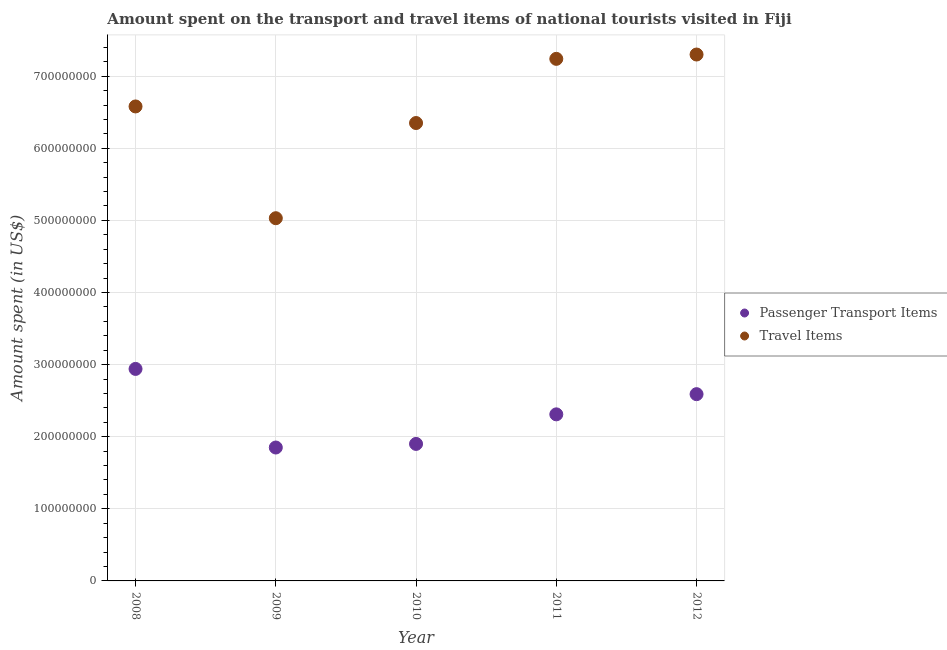What is the amount spent in travel items in 2012?
Your response must be concise. 7.30e+08. Across all years, what is the maximum amount spent in travel items?
Make the answer very short. 7.30e+08. Across all years, what is the minimum amount spent in travel items?
Keep it short and to the point. 5.03e+08. In which year was the amount spent on passenger transport items maximum?
Offer a very short reply. 2008. What is the total amount spent in travel items in the graph?
Ensure brevity in your answer.  3.25e+09. What is the difference between the amount spent on passenger transport items in 2009 and that in 2010?
Your answer should be compact. -5.00e+06. What is the difference between the amount spent in travel items in 2011 and the amount spent on passenger transport items in 2012?
Your answer should be very brief. 4.65e+08. What is the average amount spent on passenger transport items per year?
Provide a succinct answer. 2.32e+08. In the year 2009, what is the difference between the amount spent on passenger transport items and amount spent in travel items?
Offer a very short reply. -3.18e+08. What is the ratio of the amount spent in travel items in 2008 to that in 2010?
Offer a very short reply. 1.04. Is the amount spent on passenger transport items in 2009 less than that in 2010?
Your answer should be very brief. Yes. Is the difference between the amount spent in travel items in 2011 and 2012 greater than the difference between the amount spent on passenger transport items in 2011 and 2012?
Your response must be concise. Yes. What is the difference between the highest and the second highest amount spent on passenger transport items?
Your response must be concise. 3.50e+07. What is the difference between the highest and the lowest amount spent in travel items?
Ensure brevity in your answer.  2.27e+08. In how many years, is the amount spent on passenger transport items greater than the average amount spent on passenger transport items taken over all years?
Offer a very short reply. 2. How many dotlines are there?
Offer a very short reply. 2. How many years are there in the graph?
Give a very brief answer. 5. Are the values on the major ticks of Y-axis written in scientific E-notation?
Provide a succinct answer. No. Does the graph contain grids?
Your answer should be very brief. Yes. How are the legend labels stacked?
Give a very brief answer. Vertical. What is the title of the graph?
Provide a short and direct response. Amount spent on the transport and travel items of national tourists visited in Fiji. What is the label or title of the X-axis?
Keep it short and to the point. Year. What is the label or title of the Y-axis?
Keep it short and to the point. Amount spent (in US$). What is the Amount spent (in US$) in Passenger Transport Items in 2008?
Your response must be concise. 2.94e+08. What is the Amount spent (in US$) in Travel Items in 2008?
Offer a terse response. 6.58e+08. What is the Amount spent (in US$) of Passenger Transport Items in 2009?
Provide a succinct answer. 1.85e+08. What is the Amount spent (in US$) in Travel Items in 2009?
Your response must be concise. 5.03e+08. What is the Amount spent (in US$) of Passenger Transport Items in 2010?
Offer a very short reply. 1.90e+08. What is the Amount spent (in US$) of Travel Items in 2010?
Your answer should be very brief. 6.35e+08. What is the Amount spent (in US$) of Passenger Transport Items in 2011?
Your answer should be very brief. 2.31e+08. What is the Amount spent (in US$) of Travel Items in 2011?
Make the answer very short. 7.24e+08. What is the Amount spent (in US$) of Passenger Transport Items in 2012?
Keep it short and to the point. 2.59e+08. What is the Amount spent (in US$) of Travel Items in 2012?
Your answer should be very brief. 7.30e+08. Across all years, what is the maximum Amount spent (in US$) of Passenger Transport Items?
Ensure brevity in your answer.  2.94e+08. Across all years, what is the maximum Amount spent (in US$) in Travel Items?
Provide a succinct answer. 7.30e+08. Across all years, what is the minimum Amount spent (in US$) of Passenger Transport Items?
Provide a short and direct response. 1.85e+08. Across all years, what is the minimum Amount spent (in US$) of Travel Items?
Your answer should be very brief. 5.03e+08. What is the total Amount spent (in US$) of Passenger Transport Items in the graph?
Give a very brief answer. 1.16e+09. What is the total Amount spent (in US$) of Travel Items in the graph?
Provide a short and direct response. 3.25e+09. What is the difference between the Amount spent (in US$) in Passenger Transport Items in 2008 and that in 2009?
Make the answer very short. 1.09e+08. What is the difference between the Amount spent (in US$) of Travel Items in 2008 and that in 2009?
Your response must be concise. 1.55e+08. What is the difference between the Amount spent (in US$) of Passenger Transport Items in 2008 and that in 2010?
Offer a terse response. 1.04e+08. What is the difference between the Amount spent (in US$) in Travel Items in 2008 and that in 2010?
Provide a succinct answer. 2.30e+07. What is the difference between the Amount spent (in US$) in Passenger Transport Items in 2008 and that in 2011?
Keep it short and to the point. 6.30e+07. What is the difference between the Amount spent (in US$) of Travel Items in 2008 and that in 2011?
Your response must be concise. -6.60e+07. What is the difference between the Amount spent (in US$) of Passenger Transport Items in 2008 and that in 2012?
Ensure brevity in your answer.  3.50e+07. What is the difference between the Amount spent (in US$) in Travel Items in 2008 and that in 2012?
Keep it short and to the point. -7.20e+07. What is the difference between the Amount spent (in US$) of Passenger Transport Items in 2009 and that in 2010?
Ensure brevity in your answer.  -5.00e+06. What is the difference between the Amount spent (in US$) in Travel Items in 2009 and that in 2010?
Ensure brevity in your answer.  -1.32e+08. What is the difference between the Amount spent (in US$) in Passenger Transport Items in 2009 and that in 2011?
Ensure brevity in your answer.  -4.60e+07. What is the difference between the Amount spent (in US$) in Travel Items in 2009 and that in 2011?
Ensure brevity in your answer.  -2.21e+08. What is the difference between the Amount spent (in US$) of Passenger Transport Items in 2009 and that in 2012?
Make the answer very short. -7.40e+07. What is the difference between the Amount spent (in US$) in Travel Items in 2009 and that in 2012?
Offer a terse response. -2.27e+08. What is the difference between the Amount spent (in US$) of Passenger Transport Items in 2010 and that in 2011?
Your response must be concise. -4.10e+07. What is the difference between the Amount spent (in US$) of Travel Items in 2010 and that in 2011?
Your answer should be very brief. -8.90e+07. What is the difference between the Amount spent (in US$) in Passenger Transport Items in 2010 and that in 2012?
Ensure brevity in your answer.  -6.90e+07. What is the difference between the Amount spent (in US$) of Travel Items in 2010 and that in 2012?
Offer a very short reply. -9.50e+07. What is the difference between the Amount spent (in US$) of Passenger Transport Items in 2011 and that in 2012?
Your answer should be very brief. -2.80e+07. What is the difference between the Amount spent (in US$) in Travel Items in 2011 and that in 2012?
Your answer should be very brief. -6.00e+06. What is the difference between the Amount spent (in US$) in Passenger Transport Items in 2008 and the Amount spent (in US$) in Travel Items in 2009?
Give a very brief answer. -2.09e+08. What is the difference between the Amount spent (in US$) of Passenger Transport Items in 2008 and the Amount spent (in US$) of Travel Items in 2010?
Provide a short and direct response. -3.41e+08. What is the difference between the Amount spent (in US$) of Passenger Transport Items in 2008 and the Amount spent (in US$) of Travel Items in 2011?
Provide a succinct answer. -4.30e+08. What is the difference between the Amount spent (in US$) of Passenger Transport Items in 2008 and the Amount spent (in US$) of Travel Items in 2012?
Give a very brief answer. -4.36e+08. What is the difference between the Amount spent (in US$) in Passenger Transport Items in 2009 and the Amount spent (in US$) in Travel Items in 2010?
Your answer should be very brief. -4.50e+08. What is the difference between the Amount spent (in US$) of Passenger Transport Items in 2009 and the Amount spent (in US$) of Travel Items in 2011?
Your response must be concise. -5.39e+08. What is the difference between the Amount spent (in US$) of Passenger Transport Items in 2009 and the Amount spent (in US$) of Travel Items in 2012?
Provide a succinct answer. -5.45e+08. What is the difference between the Amount spent (in US$) in Passenger Transport Items in 2010 and the Amount spent (in US$) in Travel Items in 2011?
Your response must be concise. -5.34e+08. What is the difference between the Amount spent (in US$) of Passenger Transport Items in 2010 and the Amount spent (in US$) of Travel Items in 2012?
Keep it short and to the point. -5.40e+08. What is the difference between the Amount spent (in US$) in Passenger Transport Items in 2011 and the Amount spent (in US$) in Travel Items in 2012?
Provide a short and direct response. -4.99e+08. What is the average Amount spent (in US$) in Passenger Transport Items per year?
Offer a very short reply. 2.32e+08. What is the average Amount spent (in US$) of Travel Items per year?
Provide a short and direct response. 6.50e+08. In the year 2008, what is the difference between the Amount spent (in US$) in Passenger Transport Items and Amount spent (in US$) in Travel Items?
Offer a terse response. -3.64e+08. In the year 2009, what is the difference between the Amount spent (in US$) in Passenger Transport Items and Amount spent (in US$) in Travel Items?
Your response must be concise. -3.18e+08. In the year 2010, what is the difference between the Amount spent (in US$) in Passenger Transport Items and Amount spent (in US$) in Travel Items?
Offer a terse response. -4.45e+08. In the year 2011, what is the difference between the Amount spent (in US$) of Passenger Transport Items and Amount spent (in US$) of Travel Items?
Keep it short and to the point. -4.93e+08. In the year 2012, what is the difference between the Amount spent (in US$) of Passenger Transport Items and Amount spent (in US$) of Travel Items?
Give a very brief answer. -4.71e+08. What is the ratio of the Amount spent (in US$) of Passenger Transport Items in 2008 to that in 2009?
Offer a very short reply. 1.59. What is the ratio of the Amount spent (in US$) of Travel Items in 2008 to that in 2009?
Make the answer very short. 1.31. What is the ratio of the Amount spent (in US$) of Passenger Transport Items in 2008 to that in 2010?
Provide a short and direct response. 1.55. What is the ratio of the Amount spent (in US$) of Travel Items in 2008 to that in 2010?
Ensure brevity in your answer.  1.04. What is the ratio of the Amount spent (in US$) in Passenger Transport Items in 2008 to that in 2011?
Offer a terse response. 1.27. What is the ratio of the Amount spent (in US$) in Travel Items in 2008 to that in 2011?
Offer a very short reply. 0.91. What is the ratio of the Amount spent (in US$) of Passenger Transport Items in 2008 to that in 2012?
Offer a terse response. 1.14. What is the ratio of the Amount spent (in US$) in Travel Items in 2008 to that in 2012?
Your answer should be very brief. 0.9. What is the ratio of the Amount spent (in US$) in Passenger Transport Items in 2009 to that in 2010?
Keep it short and to the point. 0.97. What is the ratio of the Amount spent (in US$) of Travel Items in 2009 to that in 2010?
Make the answer very short. 0.79. What is the ratio of the Amount spent (in US$) in Passenger Transport Items in 2009 to that in 2011?
Your answer should be very brief. 0.8. What is the ratio of the Amount spent (in US$) of Travel Items in 2009 to that in 2011?
Your response must be concise. 0.69. What is the ratio of the Amount spent (in US$) of Travel Items in 2009 to that in 2012?
Offer a very short reply. 0.69. What is the ratio of the Amount spent (in US$) of Passenger Transport Items in 2010 to that in 2011?
Your response must be concise. 0.82. What is the ratio of the Amount spent (in US$) in Travel Items in 2010 to that in 2011?
Provide a succinct answer. 0.88. What is the ratio of the Amount spent (in US$) in Passenger Transport Items in 2010 to that in 2012?
Your response must be concise. 0.73. What is the ratio of the Amount spent (in US$) in Travel Items in 2010 to that in 2012?
Your answer should be very brief. 0.87. What is the ratio of the Amount spent (in US$) in Passenger Transport Items in 2011 to that in 2012?
Ensure brevity in your answer.  0.89. What is the ratio of the Amount spent (in US$) of Travel Items in 2011 to that in 2012?
Your answer should be very brief. 0.99. What is the difference between the highest and the second highest Amount spent (in US$) of Passenger Transport Items?
Your answer should be compact. 3.50e+07. What is the difference between the highest and the lowest Amount spent (in US$) of Passenger Transport Items?
Offer a terse response. 1.09e+08. What is the difference between the highest and the lowest Amount spent (in US$) of Travel Items?
Keep it short and to the point. 2.27e+08. 